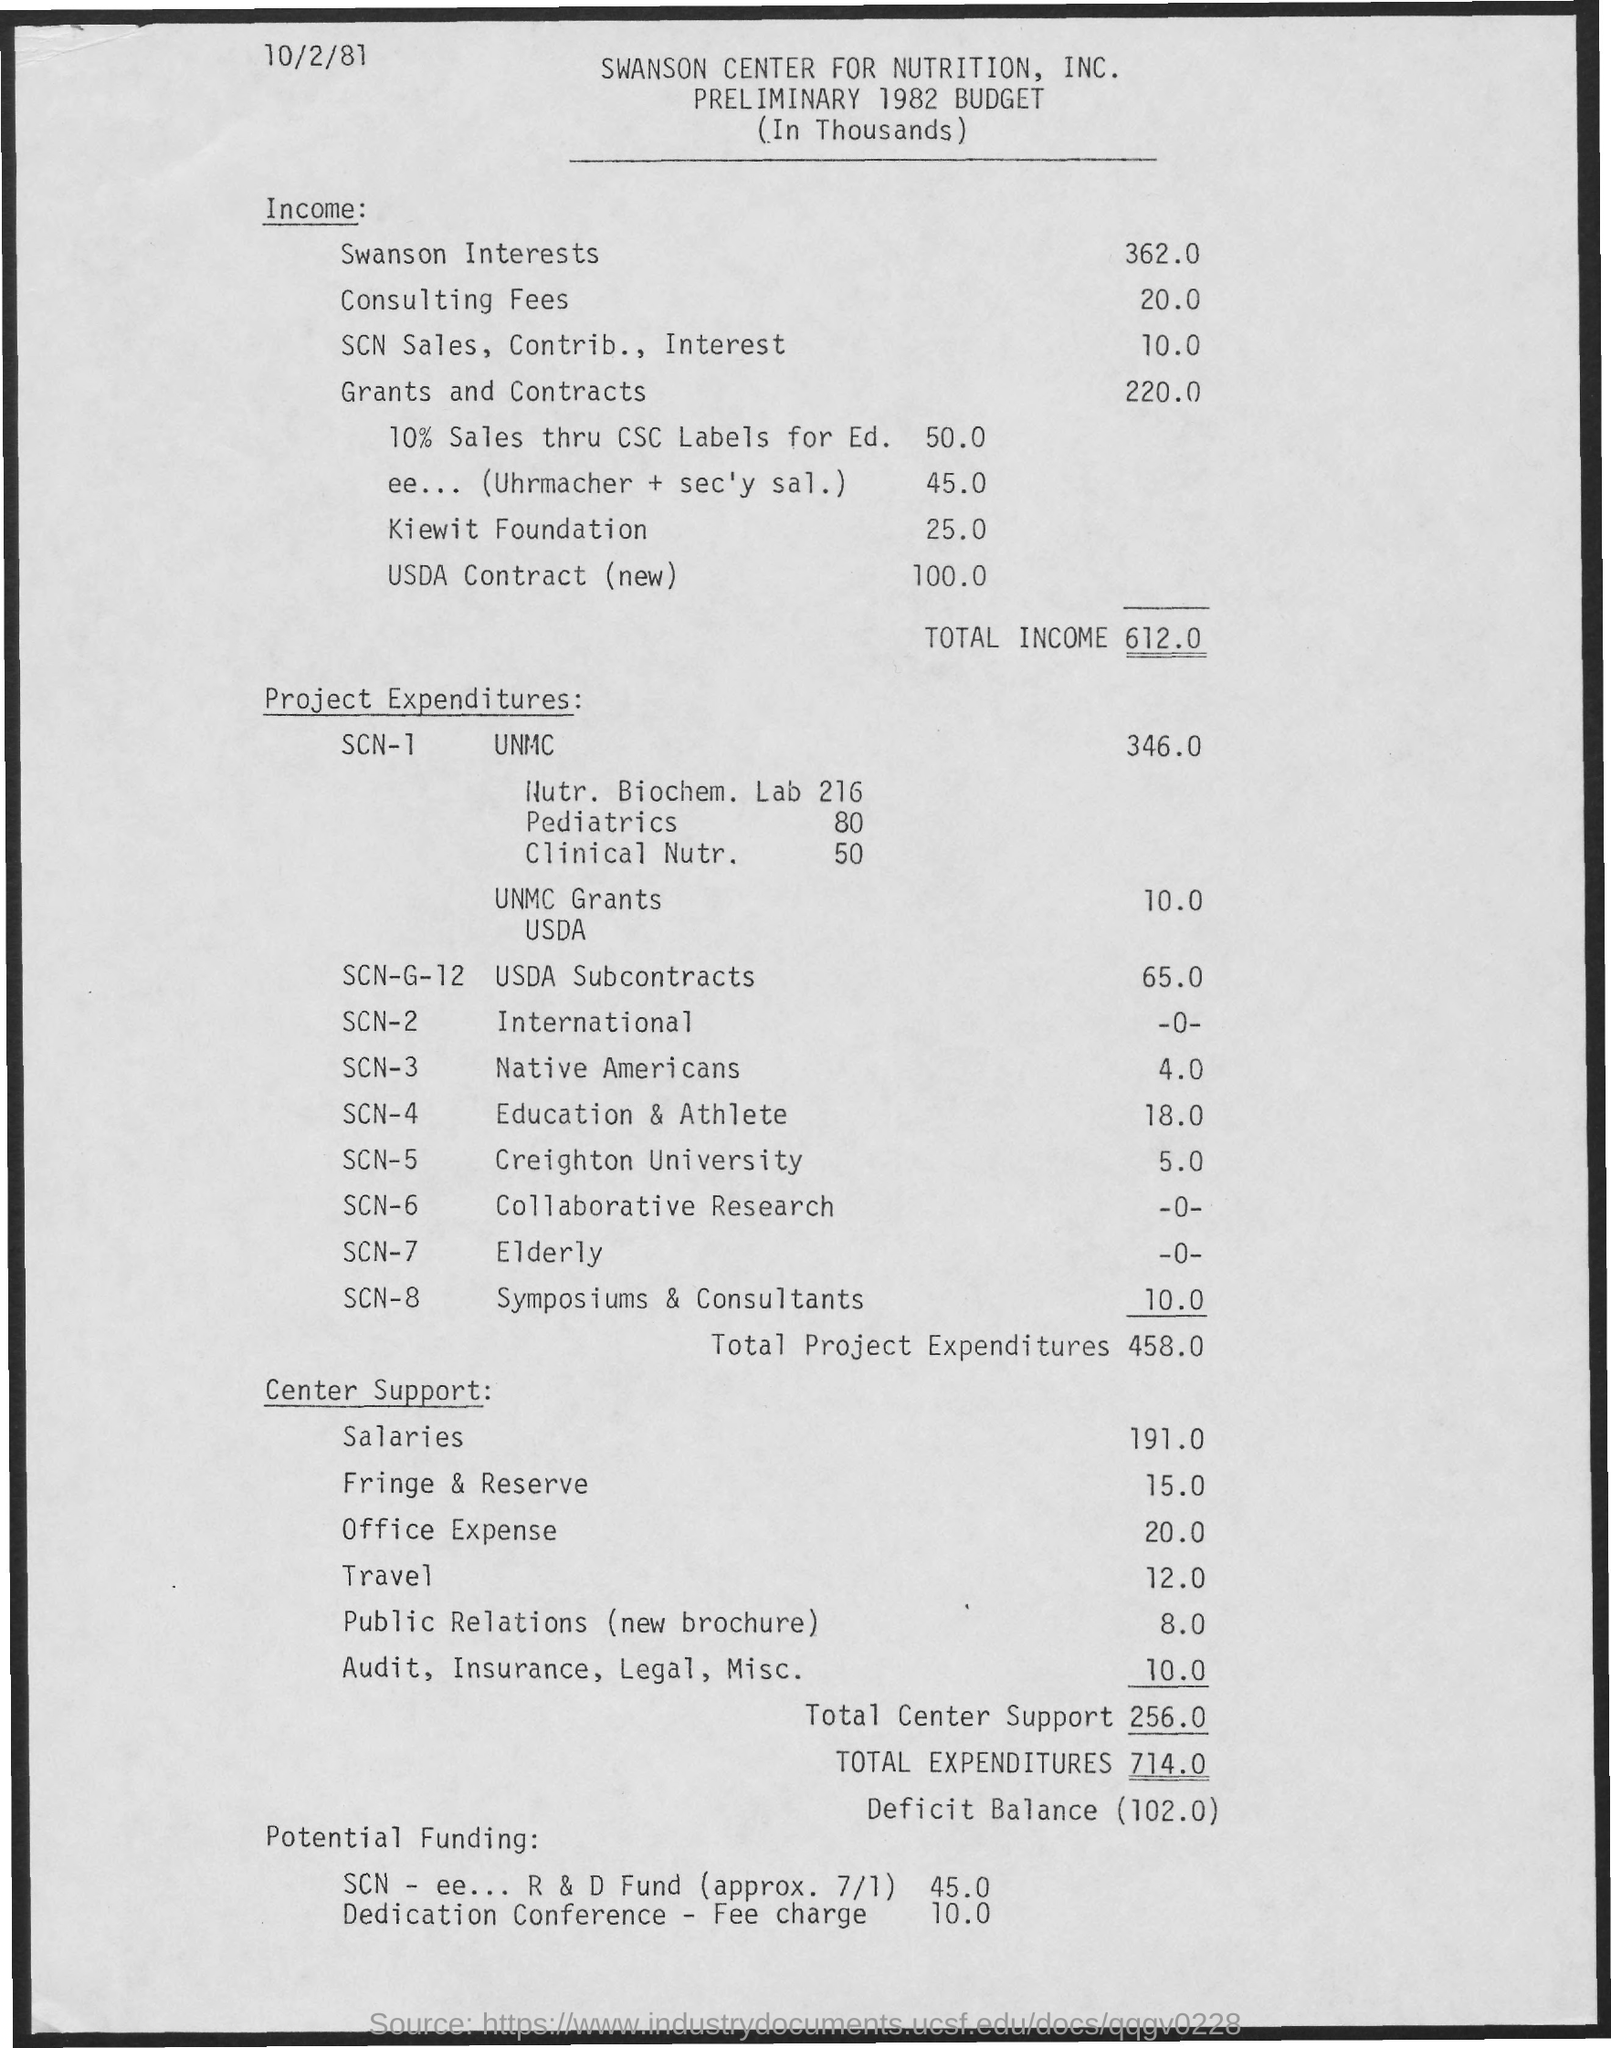Highlight a few significant elements in this photo. The consulting fees are 20.0... What is the income for Swanson Interests? The income is 362.0.. The date on the document is October 2nd, 1981. Total project expenditures are estimated to be approximately $458,000. The total expenditures are approximately 714.00. 